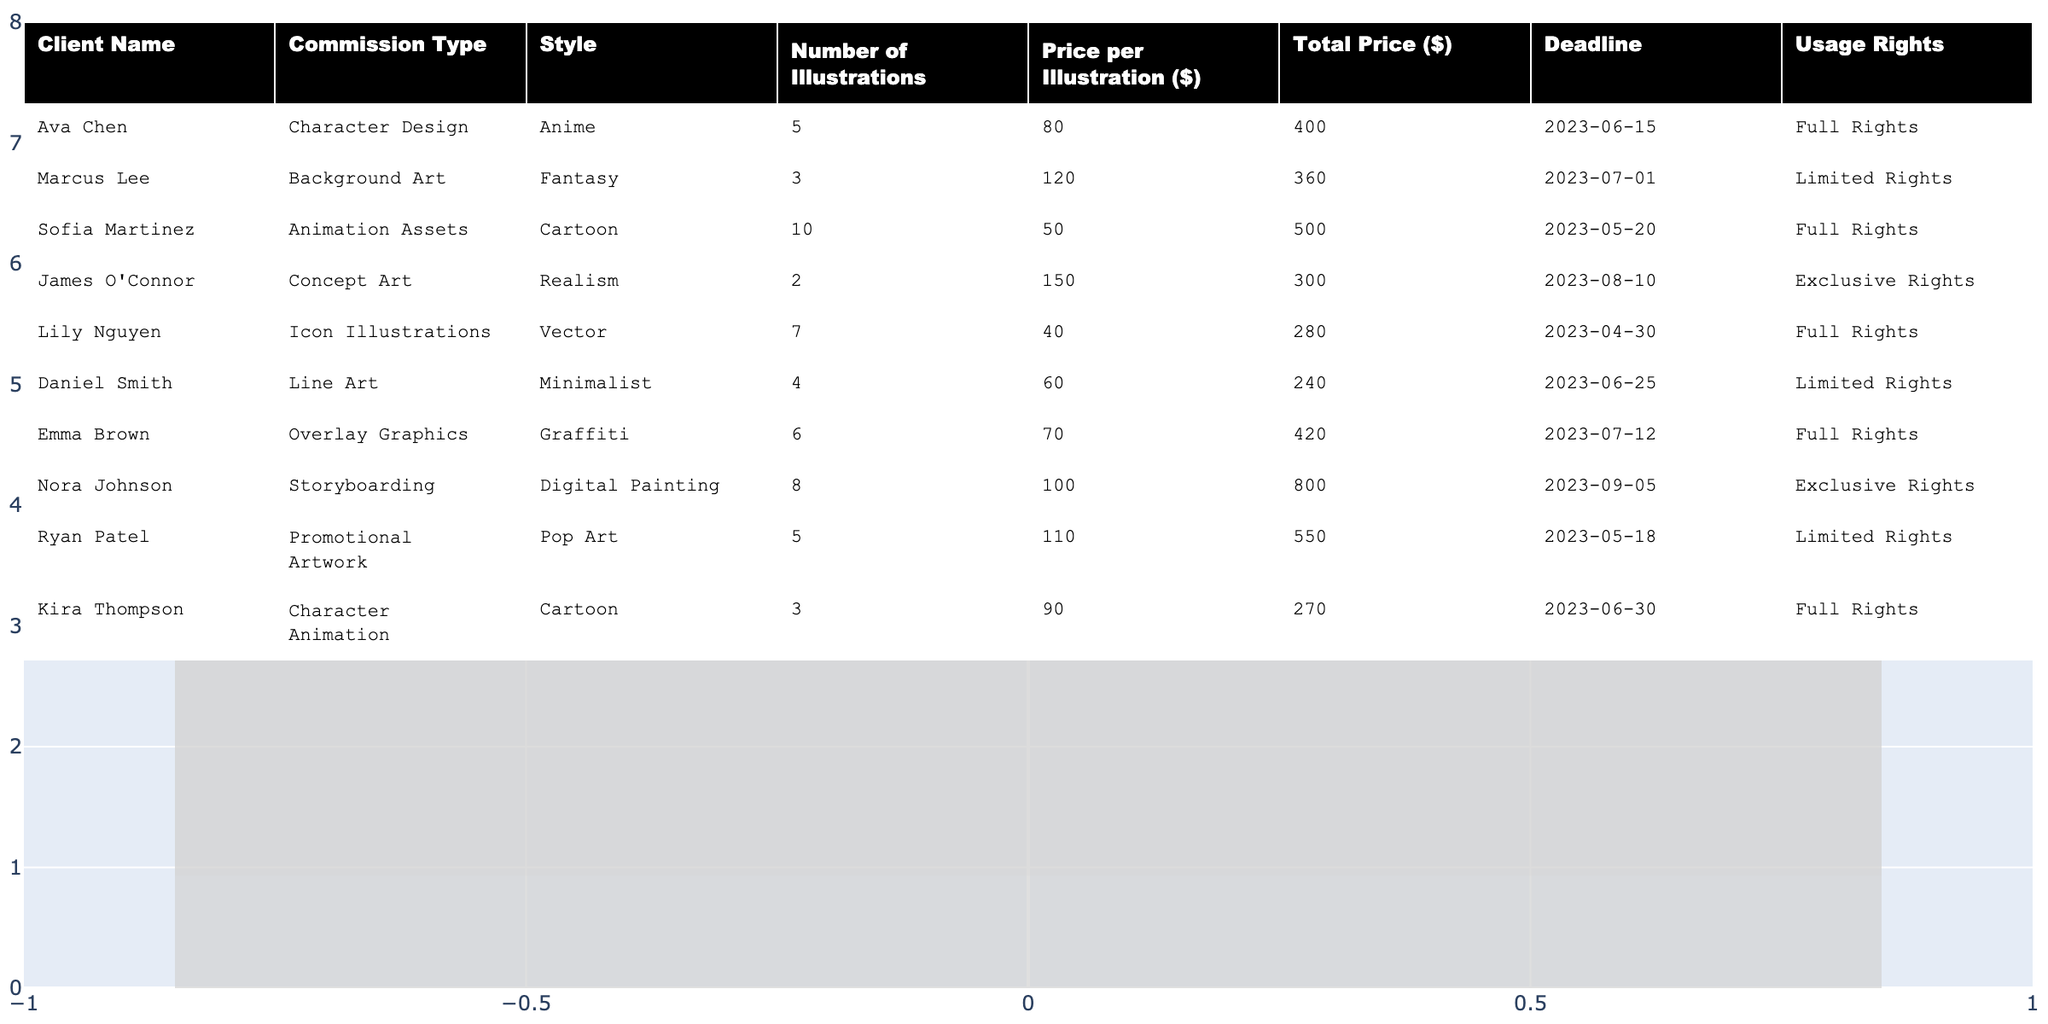What is the total price for the illustration commission from Ava Chen? The total price for Ava Chen's commission is listed in the table under the "Total Price ($)" column, which shows $400.
Answer: $400 How many illustrations did Daniel Smith request? The table shows Daniel Smith's commission under the "Number of Illustrations" column, which indicates he requested 4 illustrations.
Answer: 4 Which client requested an animation asset and what was the total price? The table indicates that Sofia Martinez requested animation assets, and the total price listed for her commission is $500.
Answer: Sofia Martinez, $500 What type of commission did Kira Thompson provide? Kira Thompson's commission type is listed under the "Commission Type" column, which shows "Character Animation."
Answer: Character Animation What is the average price per illustration for all clients? First, we find the total of the "Price per Illustration ($)" column: (80 + 120 + 50 + 150 + 40 + 60 + 70 + 100 + 110 + 90) = 1020. There are 10 clients, so we calculate the average: 1020 / 10 = 102.
Answer: $102 Did any clients request exclusive rights for their illustrations? By checking the "Usage Rights" column, it is clear that James O'Connor and Nora Johnson both requested exclusive rights for their illustrations. The answer is yes.
Answer: Yes Which illustration style has the highest total price? To find this, we look at the "Total Price ($)" column and note the highest value, which is $800 for the "Digital Painting" style by Nora Johnson.
Answer: Digital Painting How many illustrations in total were requested by all clients? We need to sum the "Number of Illustrations" column values: 5 + 3 + 10 + 2 + 7 + 4 + 6 + 8 + 5 + 3 = 53.
Answer: 53 What is the deadline for the background art commissioned by Marcus Lee? The deadline for Marcus Lee's background art is found under the "Deadline" column, where it states the date is 2023-07-01.
Answer: 2023-07-01 Which client has the earliest deadline, and what is that deadline? Looking through the "Deadline" column, we check the dates and find that Lily Nguyen has the earliest deadline of 2023-04-30.
Answer: Lily Nguyen, 2023-04-30 